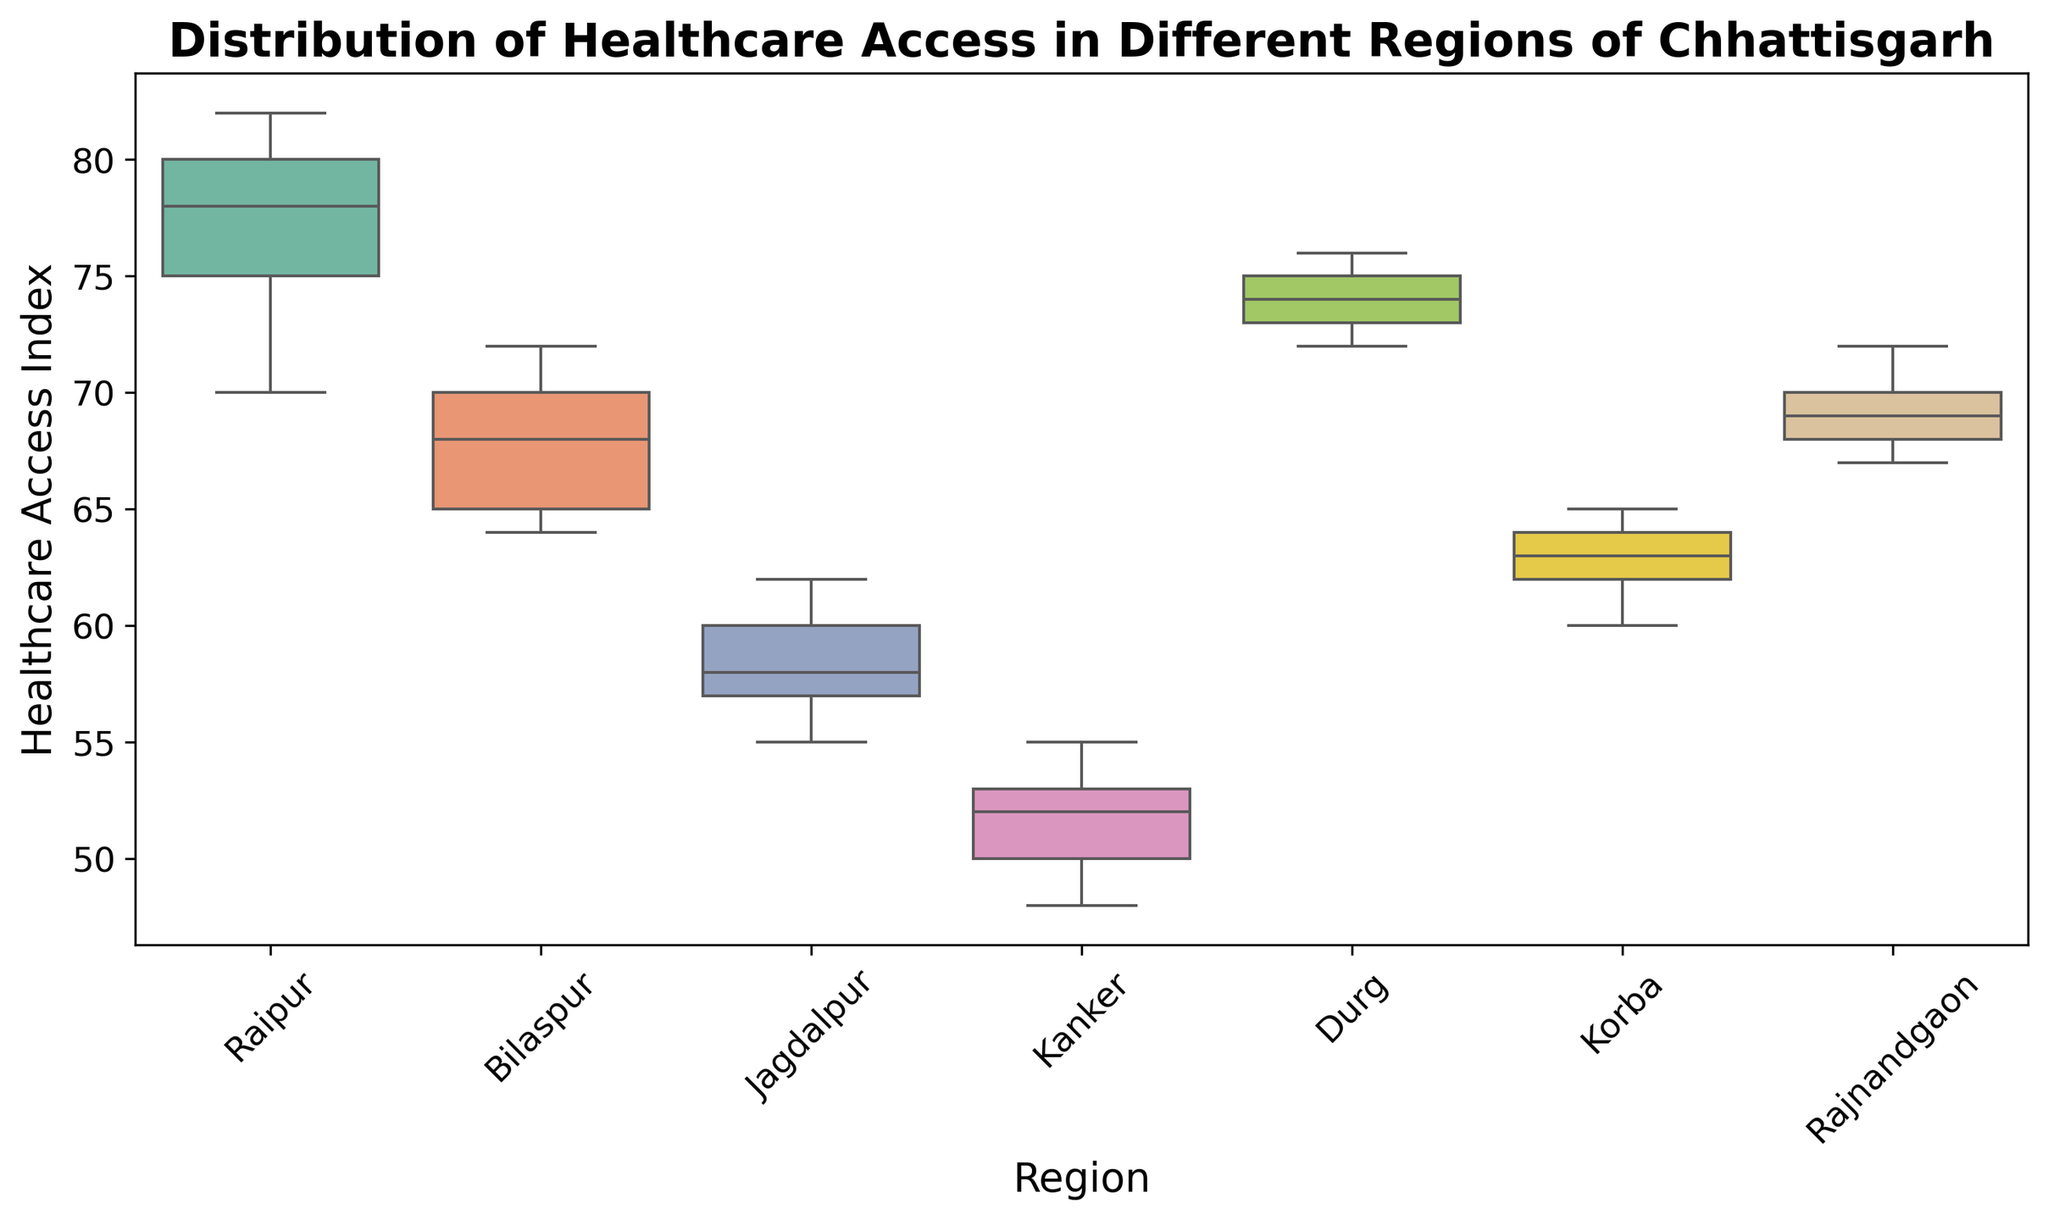What is the title of the plot? The title is typically located at the top center of the plot and is usually in a larger font size for easy visibility.
Answer: Distribution of Healthcare Access in Different Regions of Chhattisgarh Which region has the highest median healthcare access index? The median value is the line inside the box of the boxplot. By identifying the region with the highest median line, we can determine which region has the highest median healthcare access index.
Answer: Raipur What are the regions with the lowest and highest range of healthcare access indexes? The range is indicated by the distance between the bottom and top whiskers of the boxplot. To find the regions with the lowest and highest range, we compare the lengths of these whiskers across all the regions.
Answer: Kanker (lowest) and Raipur (highest) Which region has the most consistent healthcare access index? Consistency can be inferred from the smallest interquartile range (IQR), which is the length of the box in the boxplot. The region with the smallest box has the most consistent healthcare access index.
Answer: Kanker What is the approximate interquartile range (IQR) for Bilaspur? The IQR is the length of the box in the boxplot, which represents the difference between the upper quartile (Q3) and lower quartile (Q1).
Answer: About 6 (68 - 62) Which regions have healthcare access indexes without any outliers? Outliers are typically represented by individual points plotted outside the whiskers of the boxplot. Regions without such points do not have outliers.
Answer: Raipur, Bilaspur, Jagdalpur, Kanker, Durg, Rajnandgaon How does the median healthcare access index of Korba compare to Jagdalpur? The median is the line inside the box. By comparing the median lines of both Korba and Jagdalpur, we can determine which median is higher or if they are equal.
Answer: Korba's median is higher than Jagdalpur's Which region has the widest spread of healthcare access indexes? The spread can be inferred from the total length between the minimum and maximum whiskers in each boxplot. The region with the longest whiskers has the widest spread.
Answer: Raipur What is the typical shape pattern for the boxplot representing Raipur in this plot? The shape pattern includes components like the box, which contains the IQR, the median line within the box and the whiskers showing the range. Usually in the plot, notable skew or symmetry, and any outliers are included.
Answer: Box is larger, median is high, long whiskers Which regions have a similar median healthcare access index? The median is the line inside the box. By comparing the position of these lines, we can identify regions that have similar medians.
Answer: Bilaspur and Rajnandgaon 